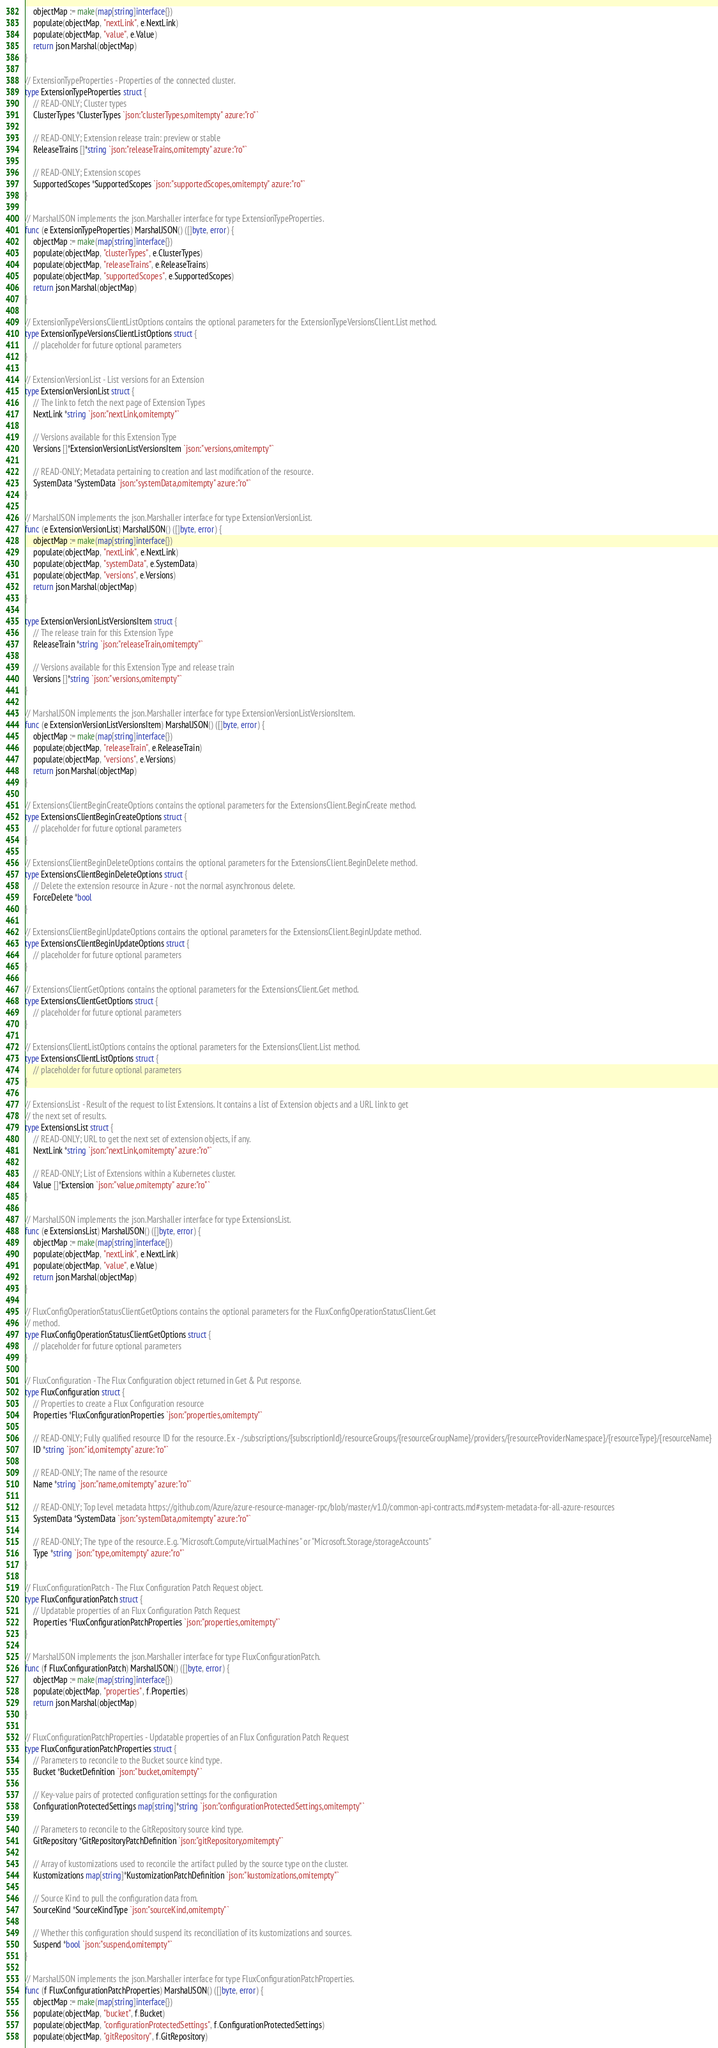Convert code to text. <code><loc_0><loc_0><loc_500><loc_500><_Go_>	objectMap := make(map[string]interface{})
	populate(objectMap, "nextLink", e.NextLink)
	populate(objectMap, "value", e.Value)
	return json.Marshal(objectMap)
}

// ExtensionTypeProperties - Properties of the connected cluster.
type ExtensionTypeProperties struct {
	// READ-ONLY; Cluster types
	ClusterTypes *ClusterTypes `json:"clusterTypes,omitempty" azure:"ro"`

	// READ-ONLY; Extension release train: preview or stable
	ReleaseTrains []*string `json:"releaseTrains,omitempty" azure:"ro"`

	// READ-ONLY; Extension scopes
	SupportedScopes *SupportedScopes `json:"supportedScopes,omitempty" azure:"ro"`
}

// MarshalJSON implements the json.Marshaller interface for type ExtensionTypeProperties.
func (e ExtensionTypeProperties) MarshalJSON() ([]byte, error) {
	objectMap := make(map[string]interface{})
	populate(objectMap, "clusterTypes", e.ClusterTypes)
	populate(objectMap, "releaseTrains", e.ReleaseTrains)
	populate(objectMap, "supportedScopes", e.SupportedScopes)
	return json.Marshal(objectMap)
}

// ExtensionTypeVersionsClientListOptions contains the optional parameters for the ExtensionTypeVersionsClient.List method.
type ExtensionTypeVersionsClientListOptions struct {
	// placeholder for future optional parameters
}

// ExtensionVersionList - List versions for an Extension
type ExtensionVersionList struct {
	// The link to fetch the next page of Extension Types
	NextLink *string `json:"nextLink,omitempty"`

	// Versions available for this Extension Type
	Versions []*ExtensionVersionListVersionsItem `json:"versions,omitempty"`

	// READ-ONLY; Metadata pertaining to creation and last modification of the resource.
	SystemData *SystemData `json:"systemData,omitempty" azure:"ro"`
}

// MarshalJSON implements the json.Marshaller interface for type ExtensionVersionList.
func (e ExtensionVersionList) MarshalJSON() ([]byte, error) {
	objectMap := make(map[string]interface{})
	populate(objectMap, "nextLink", e.NextLink)
	populate(objectMap, "systemData", e.SystemData)
	populate(objectMap, "versions", e.Versions)
	return json.Marshal(objectMap)
}

type ExtensionVersionListVersionsItem struct {
	// The release train for this Extension Type
	ReleaseTrain *string `json:"releaseTrain,omitempty"`

	// Versions available for this Extension Type and release train
	Versions []*string `json:"versions,omitempty"`
}

// MarshalJSON implements the json.Marshaller interface for type ExtensionVersionListVersionsItem.
func (e ExtensionVersionListVersionsItem) MarshalJSON() ([]byte, error) {
	objectMap := make(map[string]interface{})
	populate(objectMap, "releaseTrain", e.ReleaseTrain)
	populate(objectMap, "versions", e.Versions)
	return json.Marshal(objectMap)
}

// ExtensionsClientBeginCreateOptions contains the optional parameters for the ExtensionsClient.BeginCreate method.
type ExtensionsClientBeginCreateOptions struct {
	// placeholder for future optional parameters
}

// ExtensionsClientBeginDeleteOptions contains the optional parameters for the ExtensionsClient.BeginDelete method.
type ExtensionsClientBeginDeleteOptions struct {
	// Delete the extension resource in Azure - not the normal asynchronous delete.
	ForceDelete *bool
}

// ExtensionsClientBeginUpdateOptions contains the optional parameters for the ExtensionsClient.BeginUpdate method.
type ExtensionsClientBeginUpdateOptions struct {
	// placeholder for future optional parameters
}

// ExtensionsClientGetOptions contains the optional parameters for the ExtensionsClient.Get method.
type ExtensionsClientGetOptions struct {
	// placeholder for future optional parameters
}

// ExtensionsClientListOptions contains the optional parameters for the ExtensionsClient.List method.
type ExtensionsClientListOptions struct {
	// placeholder for future optional parameters
}

// ExtensionsList - Result of the request to list Extensions. It contains a list of Extension objects and a URL link to get
// the next set of results.
type ExtensionsList struct {
	// READ-ONLY; URL to get the next set of extension objects, if any.
	NextLink *string `json:"nextLink,omitempty" azure:"ro"`

	// READ-ONLY; List of Extensions within a Kubernetes cluster.
	Value []*Extension `json:"value,omitempty" azure:"ro"`
}

// MarshalJSON implements the json.Marshaller interface for type ExtensionsList.
func (e ExtensionsList) MarshalJSON() ([]byte, error) {
	objectMap := make(map[string]interface{})
	populate(objectMap, "nextLink", e.NextLink)
	populate(objectMap, "value", e.Value)
	return json.Marshal(objectMap)
}

// FluxConfigOperationStatusClientGetOptions contains the optional parameters for the FluxConfigOperationStatusClient.Get
// method.
type FluxConfigOperationStatusClientGetOptions struct {
	// placeholder for future optional parameters
}

// FluxConfiguration - The Flux Configuration object returned in Get & Put response.
type FluxConfiguration struct {
	// Properties to create a Flux Configuration resource
	Properties *FluxConfigurationProperties `json:"properties,omitempty"`

	// READ-ONLY; Fully qualified resource ID for the resource. Ex - /subscriptions/{subscriptionId}/resourceGroups/{resourceGroupName}/providers/{resourceProviderNamespace}/{resourceType}/{resourceName}
	ID *string `json:"id,omitempty" azure:"ro"`

	// READ-ONLY; The name of the resource
	Name *string `json:"name,omitempty" azure:"ro"`

	// READ-ONLY; Top level metadata https://github.com/Azure/azure-resource-manager-rpc/blob/master/v1.0/common-api-contracts.md#system-metadata-for-all-azure-resources
	SystemData *SystemData `json:"systemData,omitempty" azure:"ro"`

	// READ-ONLY; The type of the resource. E.g. "Microsoft.Compute/virtualMachines" or "Microsoft.Storage/storageAccounts"
	Type *string `json:"type,omitempty" azure:"ro"`
}

// FluxConfigurationPatch - The Flux Configuration Patch Request object.
type FluxConfigurationPatch struct {
	// Updatable properties of an Flux Configuration Patch Request
	Properties *FluxConfigurationPatchProperties `json:"properties,omitempty"`
}

// MarshalJSON implements the json.Marshaller interface for type FluxConfigurationPatch.
func (f FluxConfigurationPatch) MarshalJSON() ([]byte, error) {
	objectMap := make(map[string]interface{})
	populate(objectMap, "properties", f.Properties)
	return json.Marshal(objectMap)
}

// FluxConfigurationPatchProperties - Updatable properties of an Flux Configuration Patch Request
type FluxConfigurationPatchProperties struct {
	// Parameters to reconcile to the Bucket source kind type.
	Bucket *BucketDefinition `json:"bucket,omitempty"`

	// Key-value pairs of protected configuration settings for the configuration
	ConfigurationProtectedSettings map[string]*string `json:"configurationProtectedSettings,omitempty"`

	// Parameters to reconcile to the GitRepository source kind type.
	GitRepository *GitRepositoryPatchDefinition `json:"gitRepository,omitempty"`

	// Array of kustomizations used to reconcile the artifact pulled by the source type on the cluster.
	Kustomizations map[string]*KustomizationPatchDefinition `json:"kustomizations,omitempty"`

	// Source Kind to pull the configuration data from.
	SourceKind *SourceKindType `json:"sourceKind,omitempty"`

	// Whether this configuration should suspend its reconciliation of its kustomizations and sources.
	Suspend *bool `json:"suspend,omitempty"`
}

// MarshalJSON implements the json.Marshaller interface for type FluxConfigurationPatchProperties.
func (f FluxConfigurationPatchProperties) MarshalJSON() ([]byte, error) {
	objectMap := make(map[string]interface{})
	populate(objectMap, "bucket", f.Bucket)
	populate(objectMap, "configurationProtectedSettings", f.ConfigurationProtectedSettings)
	populate(objectMap, "gitRepository", f.GitRepository)</code> 